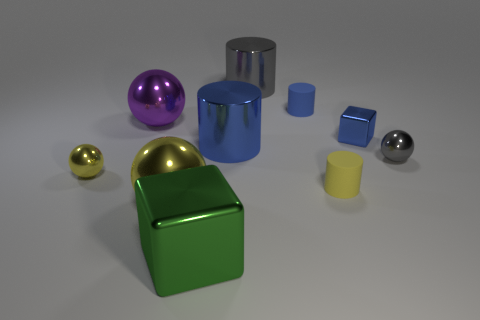How might these objects be used to teach a concept? These objects could be used to teach concepts such as geometry, by discussing their shapes; physics, by examining their reflective properties and speculating about the materials they're made from; or art, by exploring color theory and composition. 